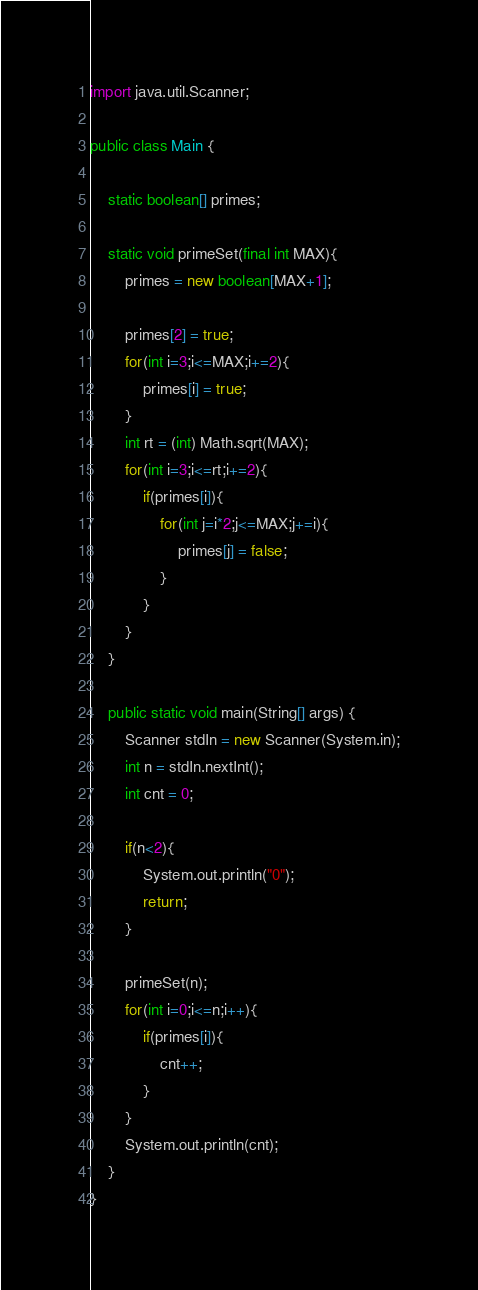Convert code to text. <code><loc_0><loc_0><loc_500><loc_500><_Java_>import java.util.Scanner;

public class Main {

	static boolean[] primes;

	static void primeSet(final int MAX){
		primes = new boolean[MAX+1];

		primes[2] = true;
		for(int i=3;i<=MAX;i+=2){
			primes[i] = true;
		}
		int rt = (int) Math.sqrt(MAX);
		for(int i=3;i<=rt;i+=2){
			if(primes[i]){
				for(int j=i*2;j<=MAX;j+=i){
					primes[j] = false;
				}
			}
		}
	}

	public static void main(String[] args) {
		Scanner stdIn = new Scanner(System.in);
		int n = stdIn.nextInt();
		int cnt = 0;
		
		if(n<2){
			System.out.println("0");
			return;
		}
		
		primeSet(n);
		for(int i=0;i<=n;i++){
			if(primes[i]){
				cnt++;
			}
		}
		System.out.println(cnt);
	}		
}</code> 